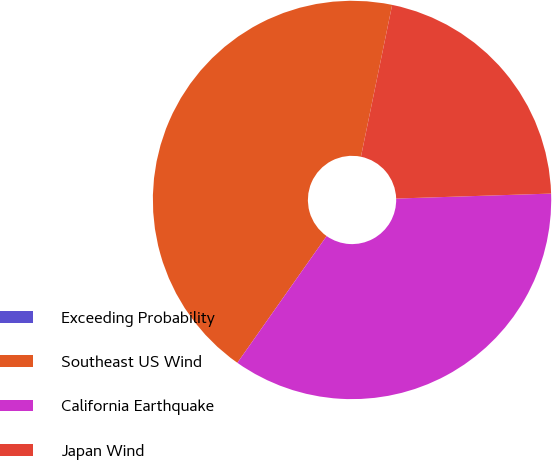Convert chart to OTSL. <chart><loc_0><loc_0><loc_500><loc_500><pie_chart><fcel>Exceeding Probability<fcel>Southeast US Wind<fcel>California Earthquake<fcel>Japan Wind<nl><fcel>0.0%<fcel>43.46%<fcel>35.27%<fcel>21.26%<nl></chart> 